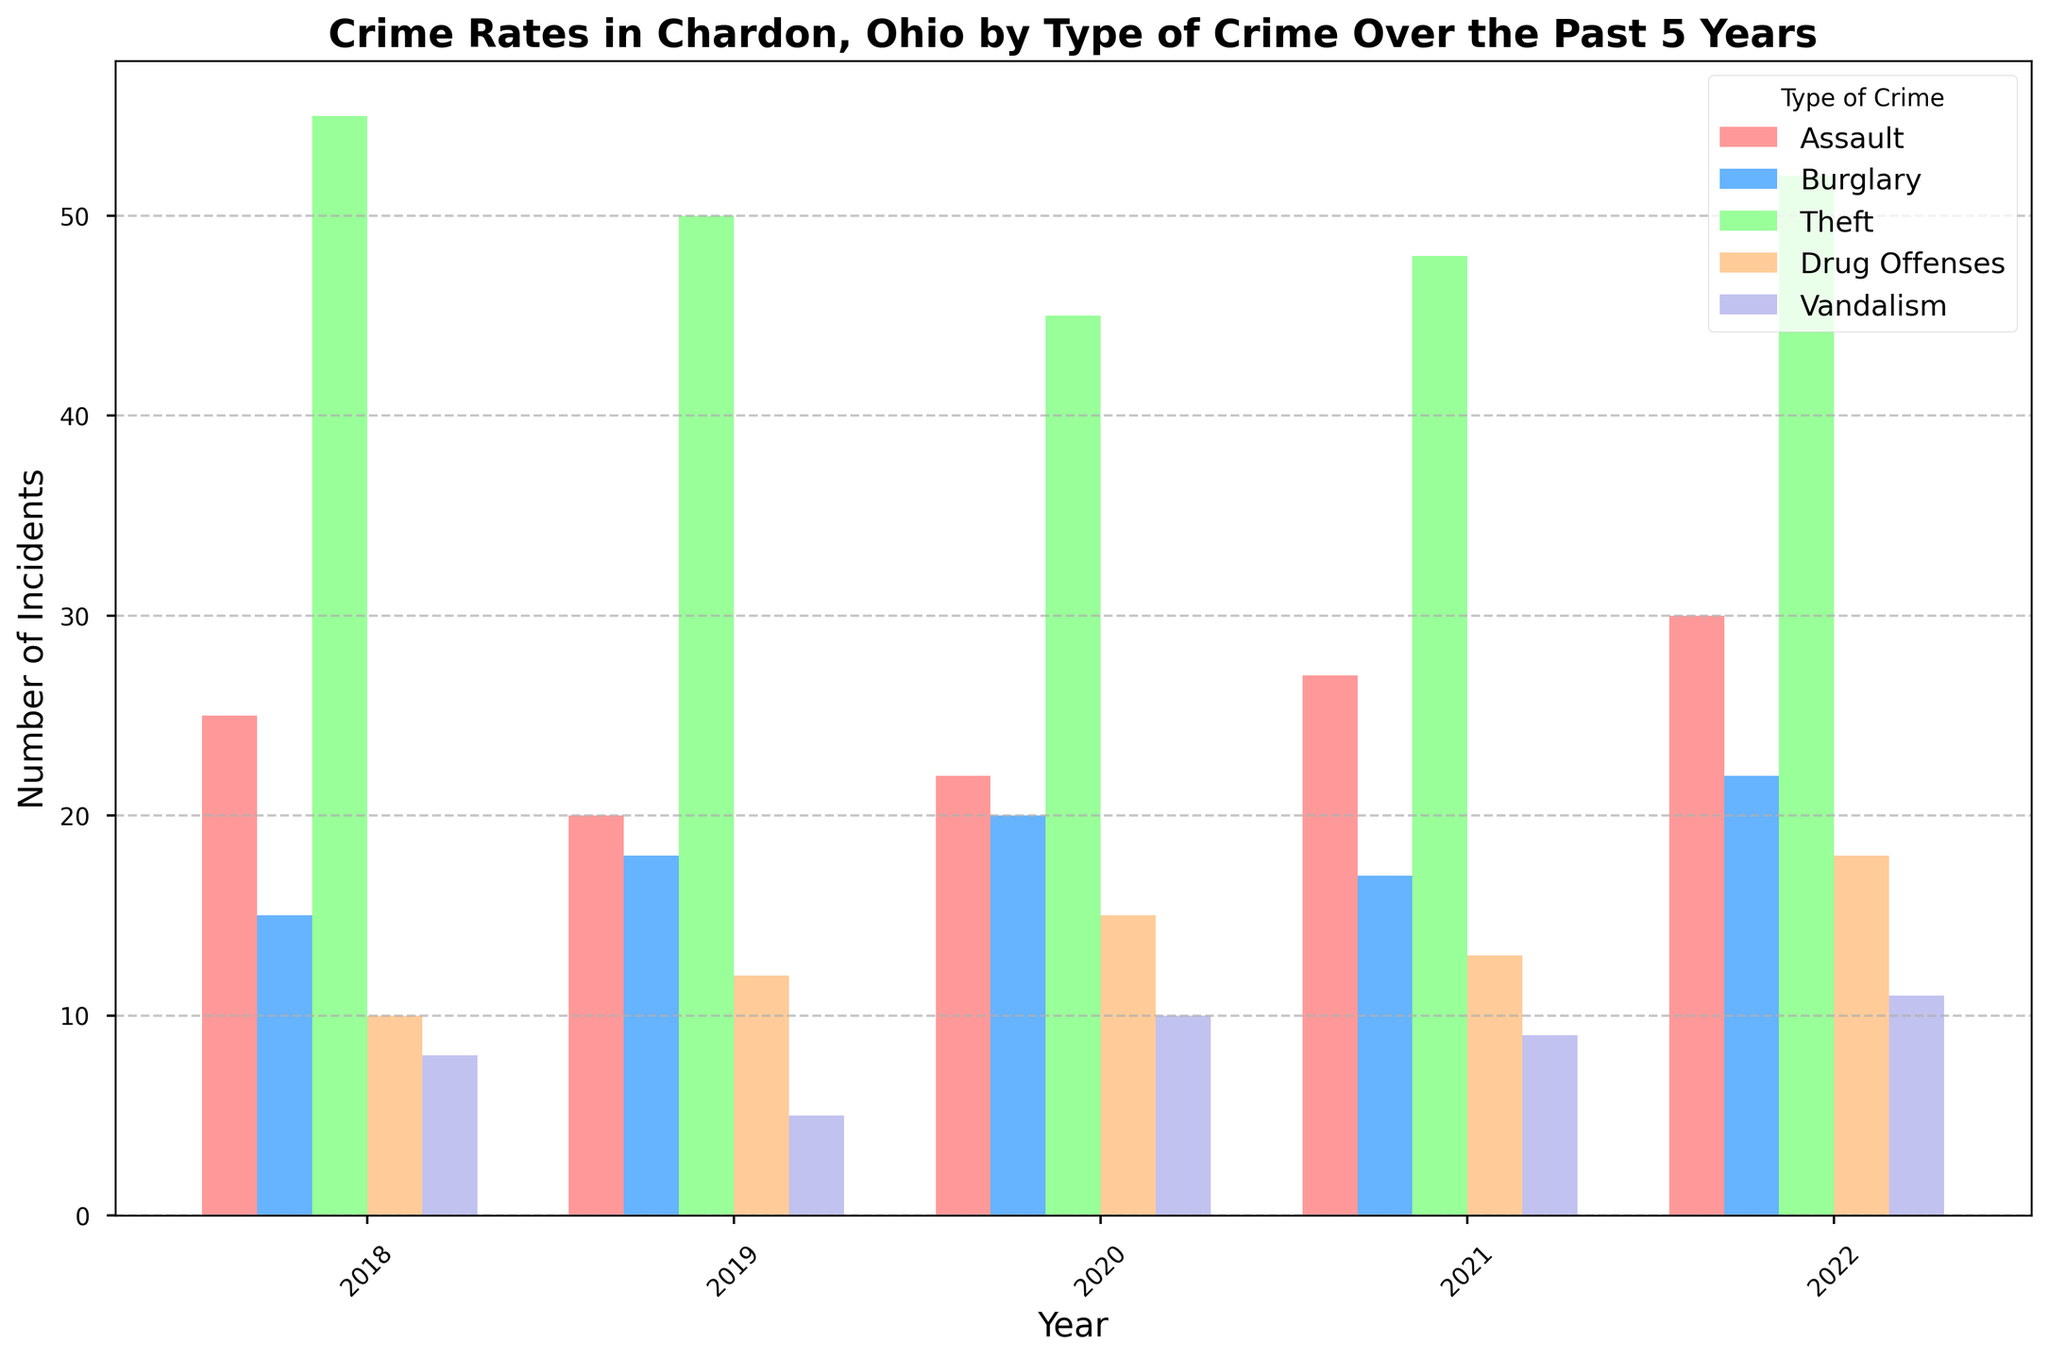Which type of crime had the highest number of incidents in 2022? Look for the highest bar corresponding to the year 2022. Identify the color and match it with the legend to find the crime type.
Answer: Theft By how much did the number of vandalism incidents change from 2019 to 2020? Find the heights of the bars for vandalism in 2019 and 2020, and calculate the difference.
Answer: +5 Which year had the highest number of drug offenses? Compare the heights of the bars related to drug offenses across all years and find the tallest one.
Answer: 2022 What was the total number of incidents of burglary over the 5 years? Sum up the heights of the bars for burglary for all the years.
Answer: 92 How does the number of assault incidents in 2018 compare to that in 2021? Note the heights of the bars for assault in 2018 and 2021 and compare them.
Answer: The number of incidents increased by 2 What is the average number of theft incidents per year over the 5 years? Add the number of theft incidents for all years and divide by 5. (55+50+45+48+52)/5
Answer: 50 In which year did the fewest vandalism incidents occur? Compare the heights of the bars for vandalism across all years and find the shortest one.
Answer: 2019 By how much did the number of burglary incidents increase from 2018 to 2019? Look at the heights of the burglary bars for 2018 and 2019, then subtract the 2018 value from the 2019 value.
Answer: +3 Which crime saw the highest increase in incidents from 2018 to 2022? Calculate the difference in the number of incidents for each crime type between 2018 and 2022 and find the largest increase.
Answer: Assault What is the difference between the total incidents of theft and drug offenses in 2020? Find the heights of the bars for theft and drug offenses in 2020 and subtract the drug offenses value from the theft value.
Answer: 30 